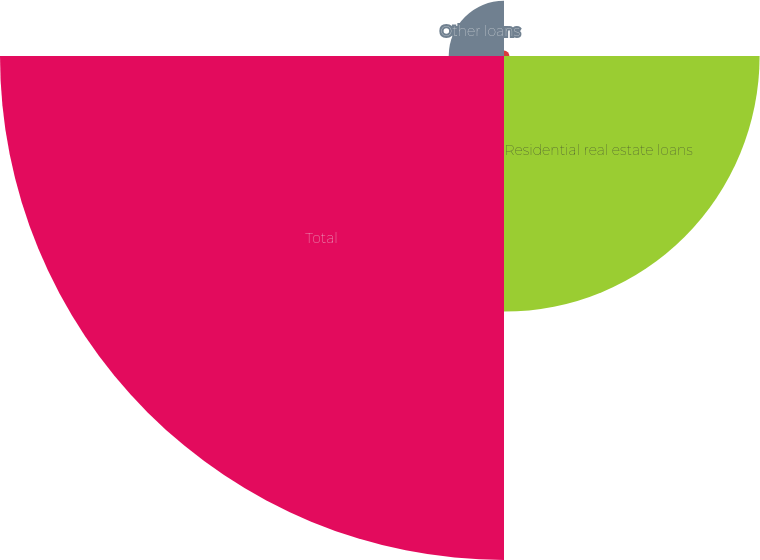<chart> <loc_0><loc_0><loc_500><loc_500><pie_chart><fcel>Commercial real estate loans<fcel>Residential real estate loans<fcel>Total<fcel>Other loans<nl><fcel>0.66%<fcel>31.16%<fcel>61.44%<fcel>6.74%<nl></chart> 